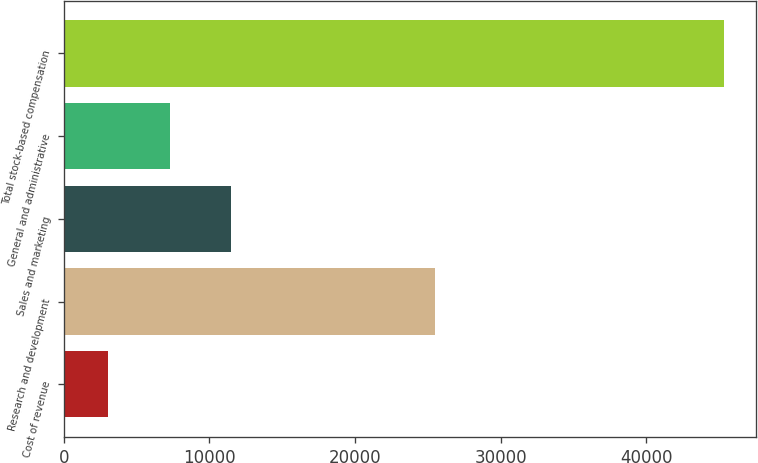Convert chart to OTSL. <chart><loc_0><loc_0><loc_500><loc_500><bar_chart><fcel>Cost of revenue<fcel>Research and development<fcel>Sales and marketing<fcel>General and administrative<fcel>Total stock-based compensation<nl><fcel>3048<fcel>25515<fcel>11499<fcel>7273.5<fcel>45303<nl></chart> 